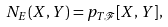<formula> <loc_0><loc_0><loc_500><loc_500>N _ { E } ( X , Y ) = p _ { T \mathcal { F } } [ X , Y ] ,</formula> 